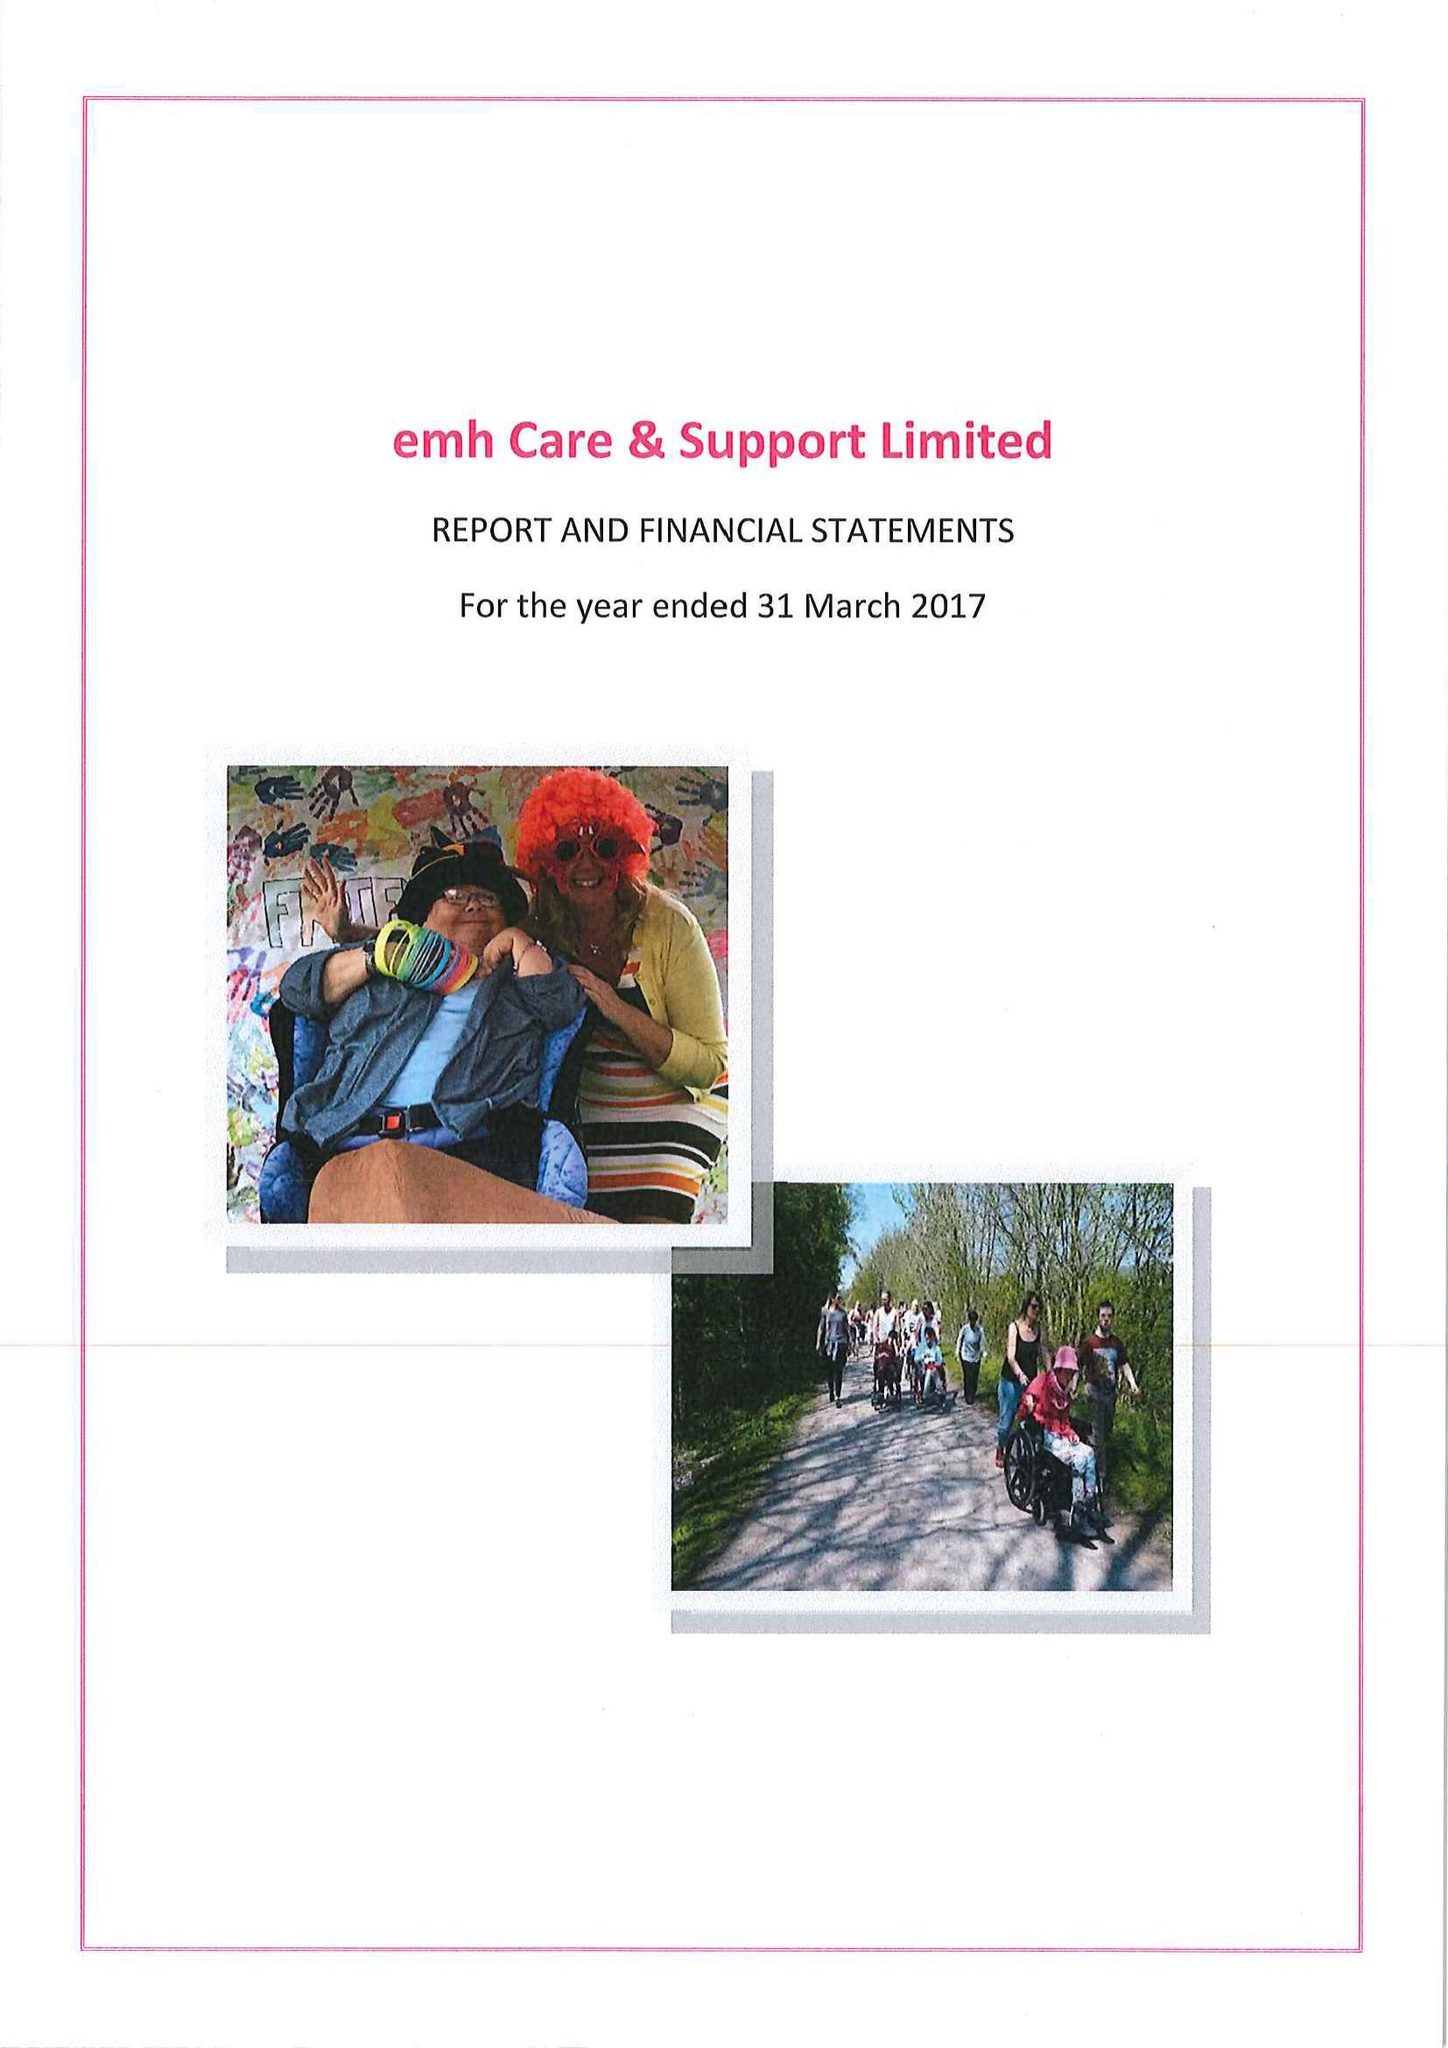What is the value for the address__post_town?
Answer the question using a single word or phrase. COALVILLE 